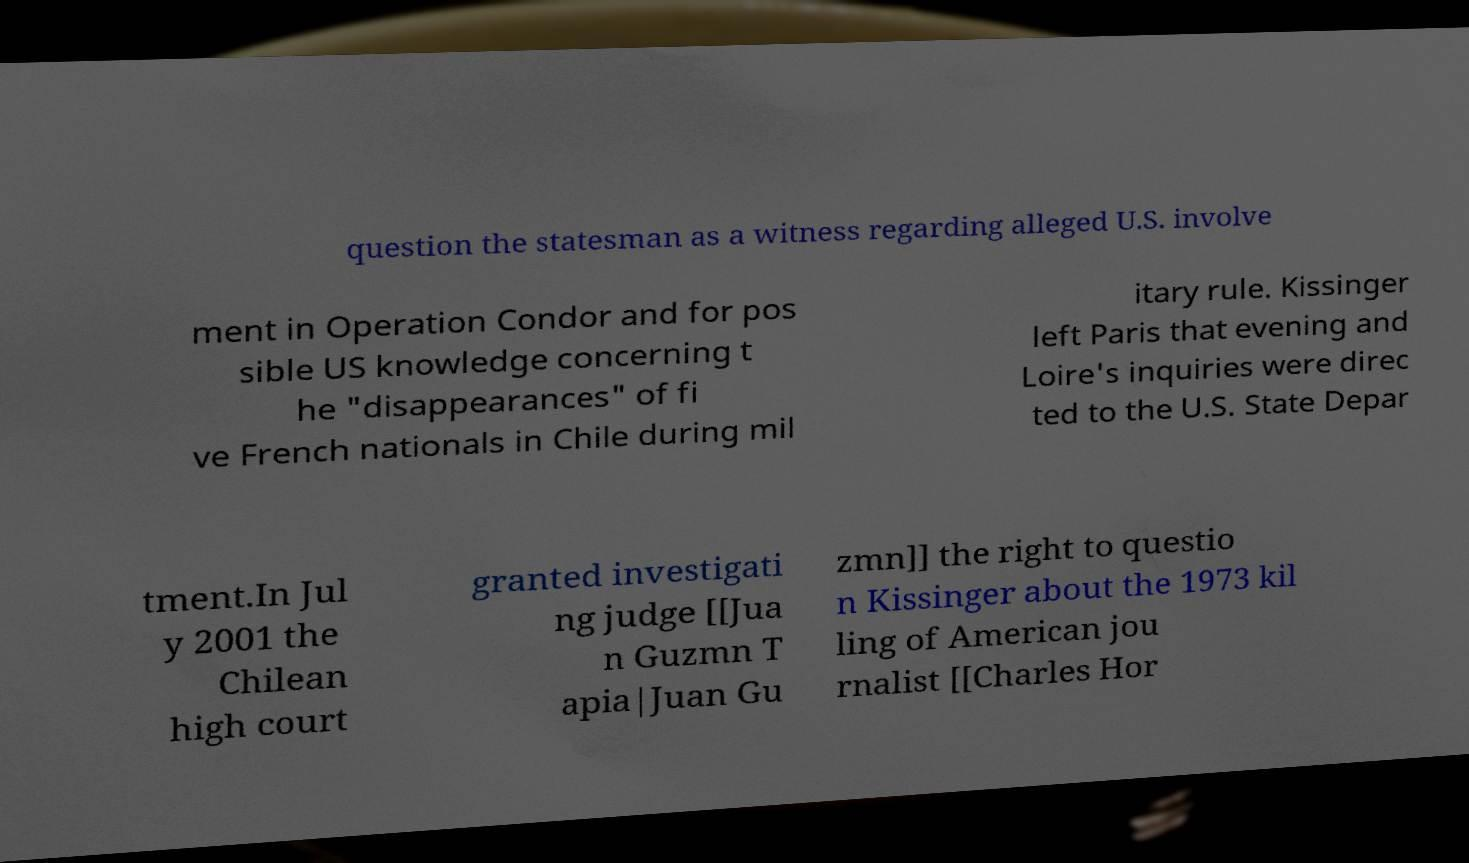Please identify and transcribe the text found in this image. question the statesman as a witness regarding alleged U.S. involve ment in Operation Condor and for pos sible US knowledge concerning t he "disappearances" of fi ve French nationals in Chile during mil itary rule. Kissinger left Paris that evening and Loire's inquiries were direc ted to the U.S. State Depar tment.In Jul y 2001 the Chilean high court granted investigati ng judge [[Jua n Guzmn T apia|Juan Gu zmn]] the right to questio n Kissinger about the 1973 kil ling of American jou rnalist [[Charles Hor 